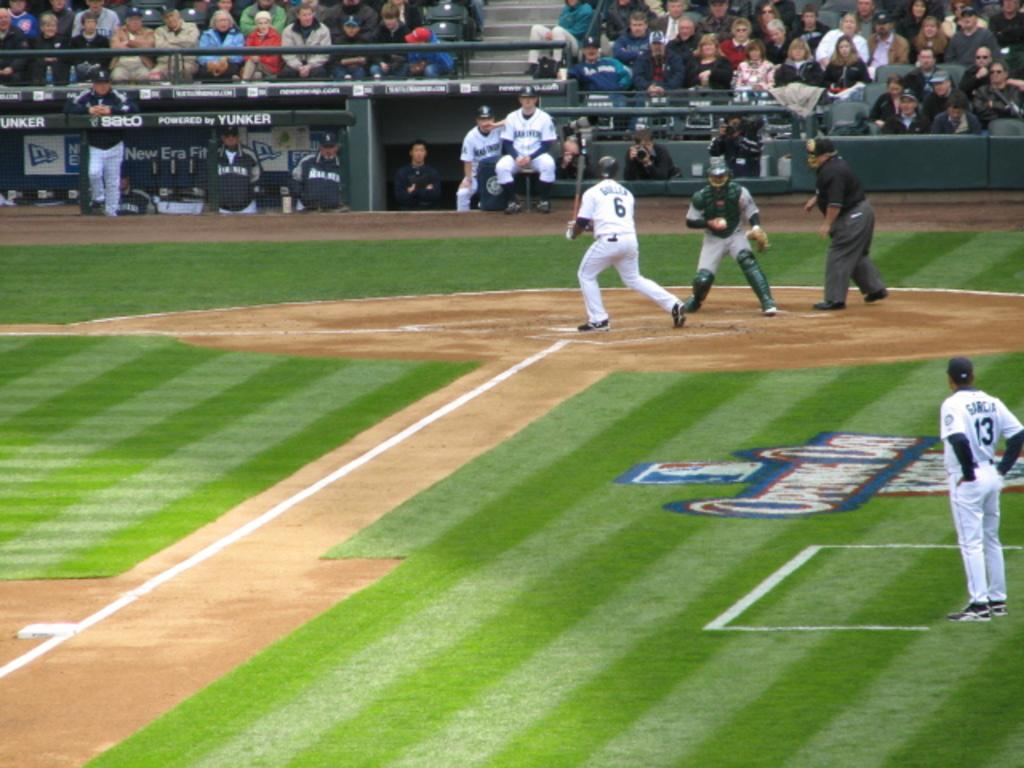What type of people can be seen in the background of the image? There are spectators in the background of the image. Who else is present in the image besides the spectators? There are sportspersons in the image. What type of location is visible in the image? There is a ground visible in the image. What type of hole can be seen in the image? There is no hole present in the image. How many boys are visible in the image? The provided facts do not mention any boys in the image, so we cannot determine the number of boys present. 